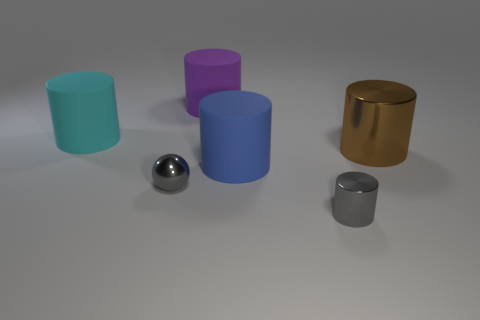Does the tiny cylinder have the same color as the ball?
Provide a short and direct response. Yes. There is a tiny object that is the same color as the small metallic ball; what shape is it?
Your answer should be compact. Cylinder. Is there a small gray cylinder made of the same material as the ball?
Give a very brief answer. Yes. How many matte things are either large cyan things or large things?
Your answer should be compact. 3. What shape is the metallic object that is on the left side of the large blue matte cylinder to the left of the small gray cylinder?
Offer a terse response. Sphere. Are there fewer big blue cylinders that are to the left of the large brown metallic cylinder than cylinders?
Provide a succinct answer. Yes. What shape is the cyan rubber object?
Offer a very short reply. Cylinder. What size is the gray shiny object that is to the left of the small gray cylinder?
Your response must be concise. Small. What is the color of the shiny cylinder that is the same size as the cyan object?
Your answer should be very brief. Brown. Is there a sphere that has the same color as the small cylinder?
Offer a terse response. Yes. 